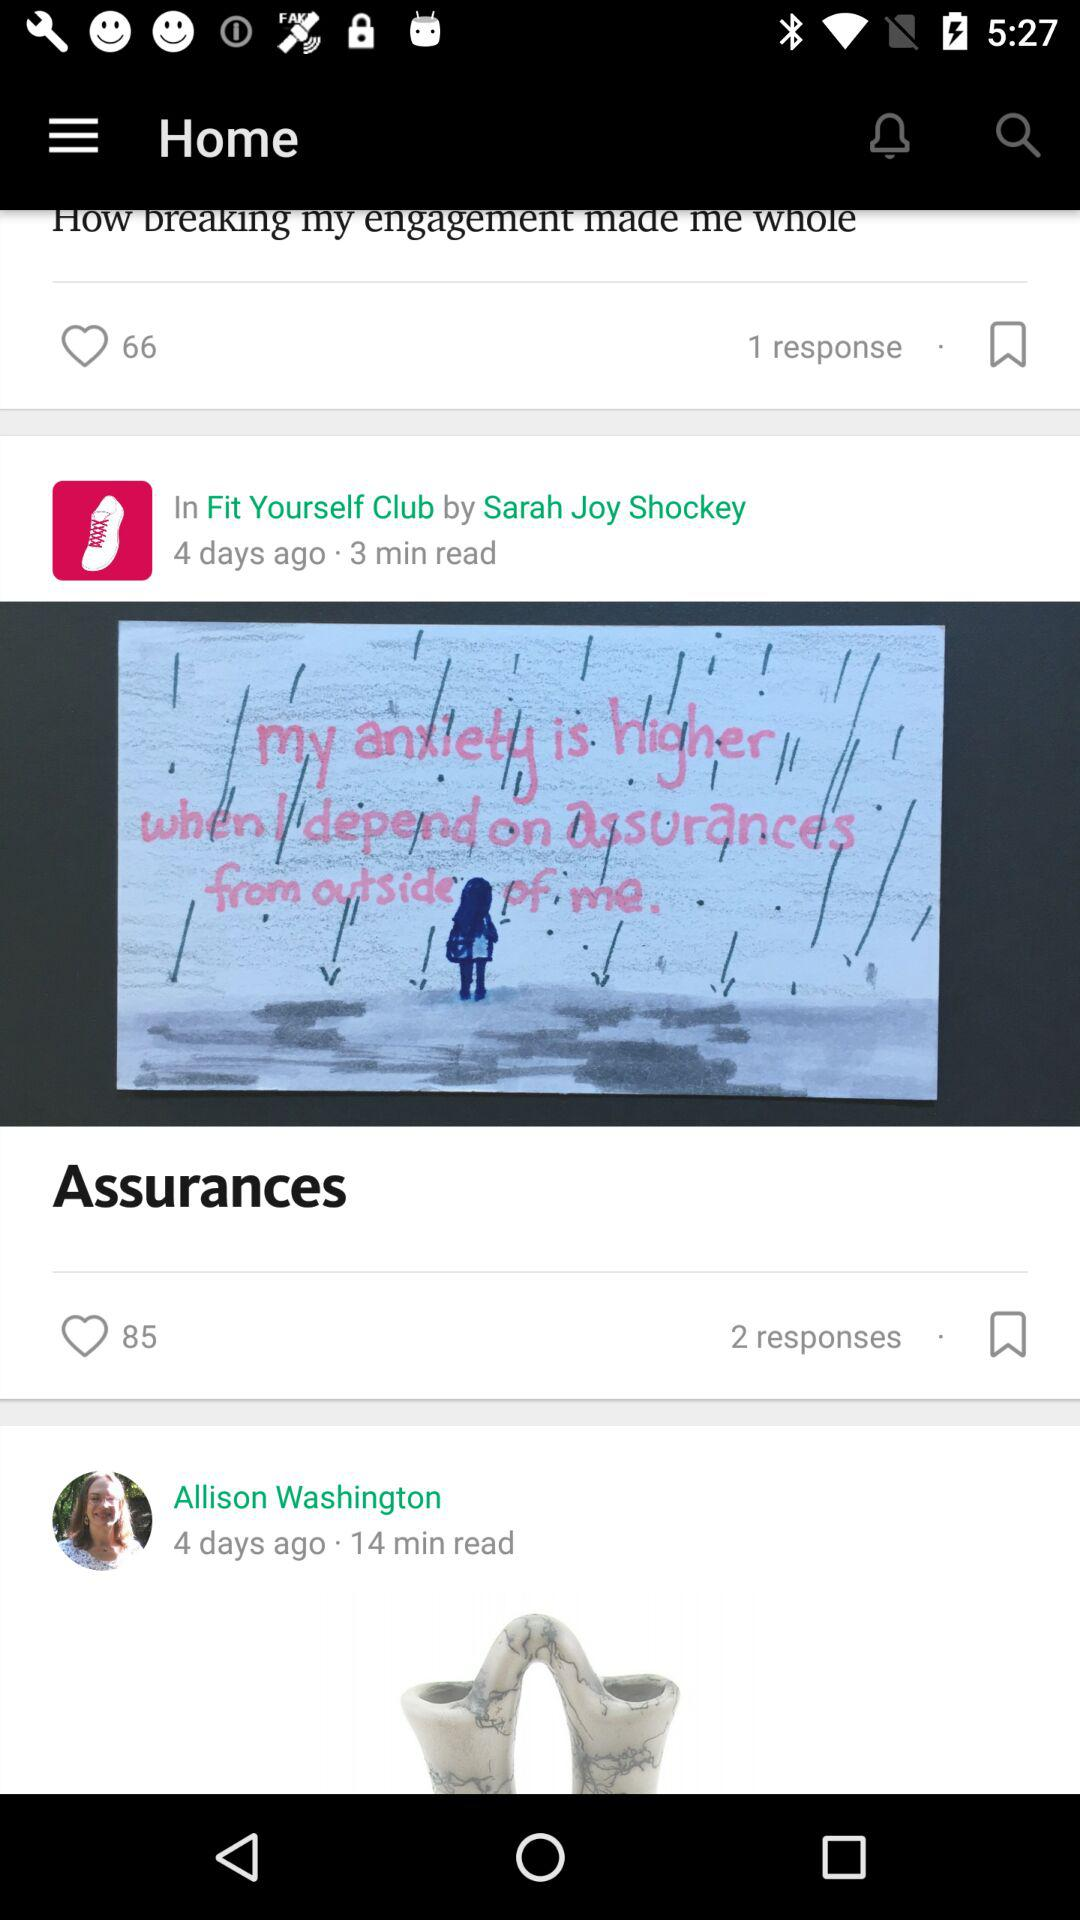How many more hearts does the Assurances article have than the How breaking my engagement made me whole article? The article titled 'Assurances' has received 85 hearts, which is 19 more than the 66 hearts for the article 'How breaking my engagement made me whole.' 